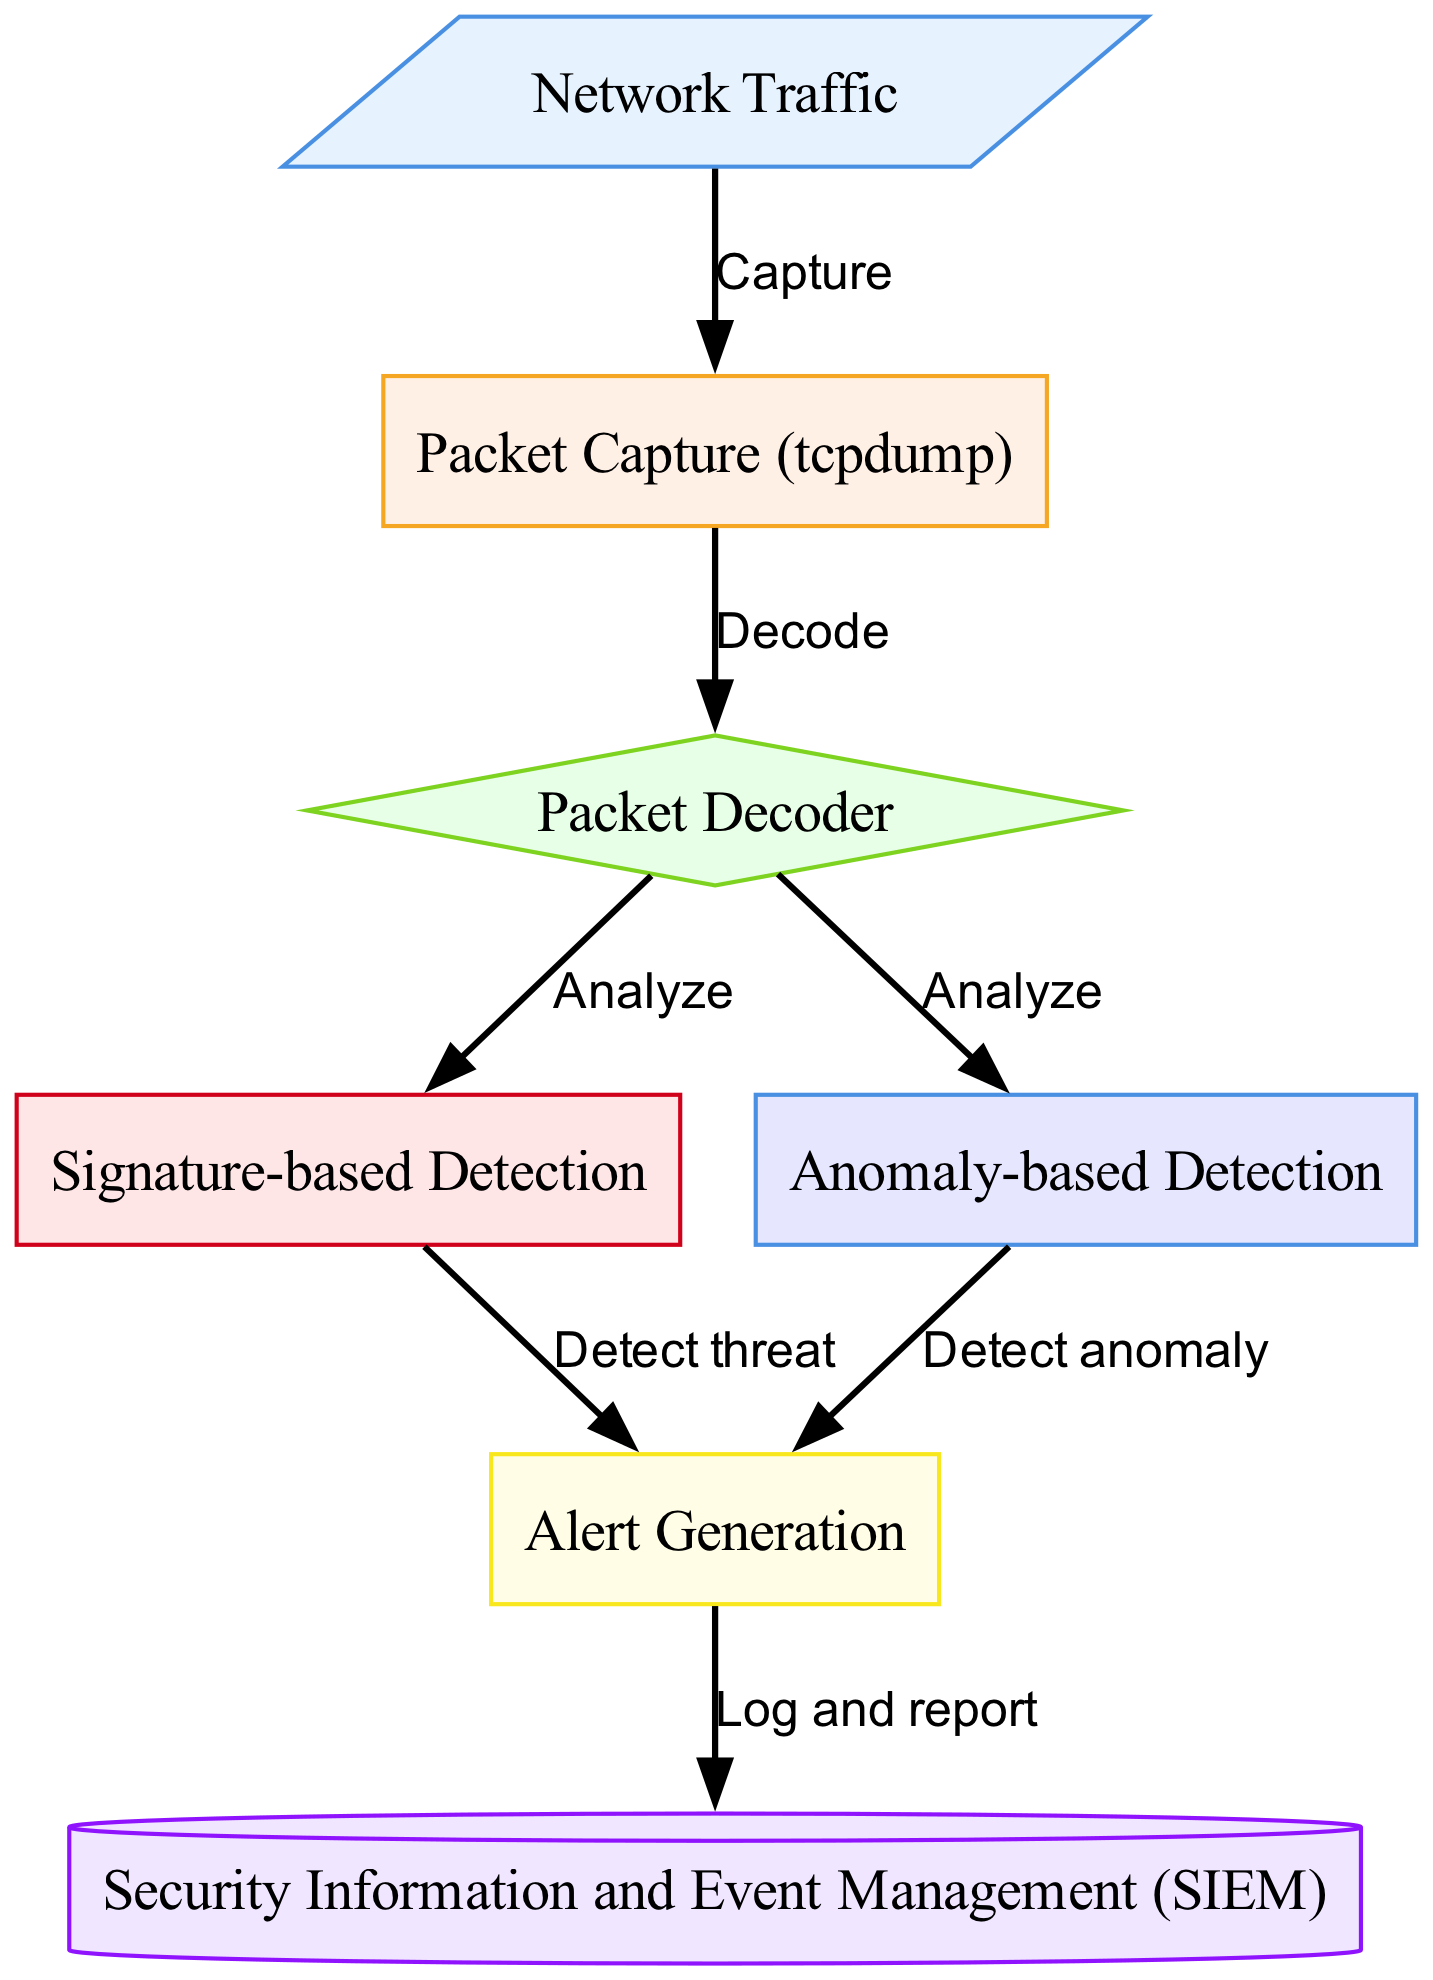What is the initial node in the workflow? The initial node in the workflow is the starting point, which in this case is "Network Traffic." This can be identified as the first node presented in the diagram.
Answer: Network Traffic How many nodes are in the diagram? By counting the nodes listed in the provided data, we can ascertain that there are seven distinct nodes in the diagram.
Answer: 7 What action occurs between 'Packet Capture (tcpdump)' and 'Packet Decoder'? The action that occurs between these two nodes is "Decode," as indicated in the edge connecting them.
Answer: Decode What kind of detection follows the 'Packet Decoder'? There are two types of detection that follow the 'Packet Decoder': "Signature-based Detection" and "Anomaly-based Detection." Both actions branch out from the 'Packet Decoder.'
Answer: Signature-based Detection and Anomaly-based Detection What does the 'Alert Generation' node depend on? The 'Alert Generation' node depends on outputs from both the "Signature-based Detection" and the "Anomaly-based Detection" nodes, meaning it requires input from both detection types to generate alerts.
Answer: Signature-based Detection and Anomaly-based Detection Describe the final step in the workflow. The final step in the workflow involves 'Security Information and Event Management (SIEM)', which occurs after 'Alert Generation'. This step logs and reports the generated alerts.
Answer: SIEM Which nodes are responsible for detecting threats? The node responsible for detecting threats is "Signature-based Detection," which directly leads to the 'Alert Generation' node, indicating it plays a key role in the detection process.
Answer: Signature-based Detection What is the shape of the 'Packet Decoder' node? The 'Packet Decoder' node is represented as a 'diamond' shape according to the node styling rules defined in the diagram.
Answer: Diamond How does 'Alert Generation' communicate its findings? 'Alert Generation' communicates its findings through logging and reporting them to the 'Security Information and Event Management (SIEM)' node. This relationship is indicated via the directed edge in the flowchart.
Answer: Log and report 